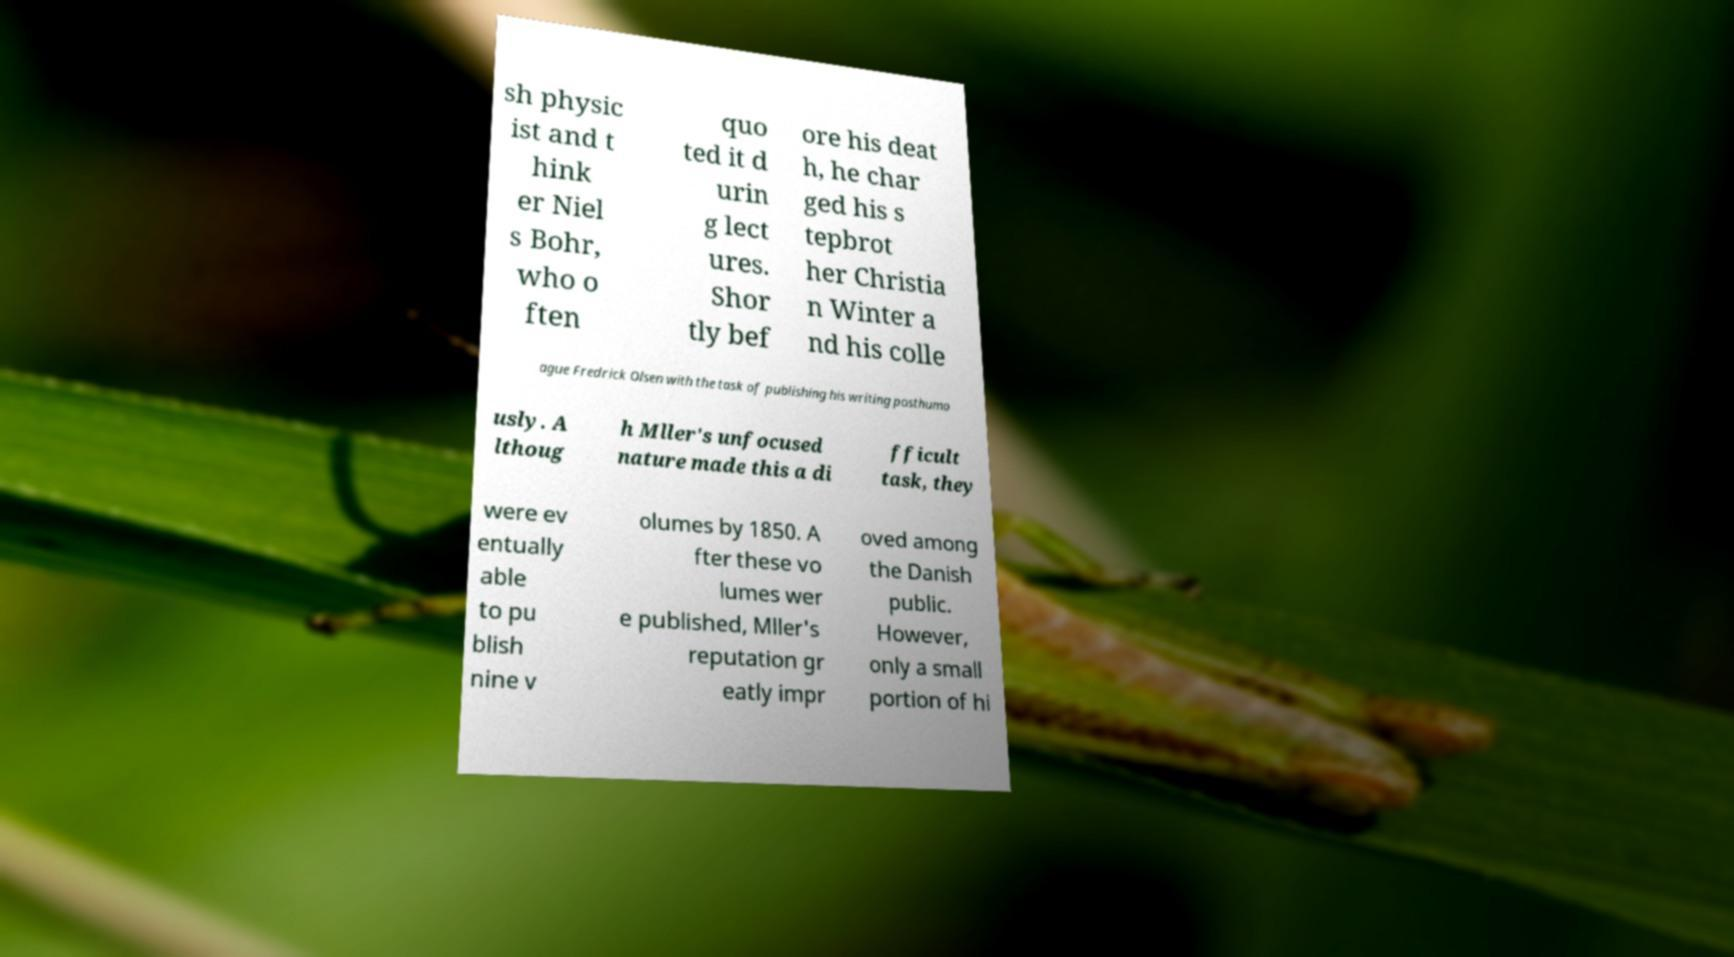Could you assist in decoding the text presented in this image and type it out clearly? sh physic ist and t hink er Niel s Bohr, who o ften quo ted it d urin g lect ures. Shor tly bef ore his deat h, he char ged his s tepbrot her Christia n Winter a nd his colle ague Fredrick Olsen with the task of publishing his writing posthumo usly. A lthoug h Mller's unfocused nature made this a di fficult task, they were ev entually able to pu blish nine v olumes by 1850. A fter these vo lumes wer e published, Mller's reputation gr eatly impr oved among the Danish public. However, only a small portion of hi 